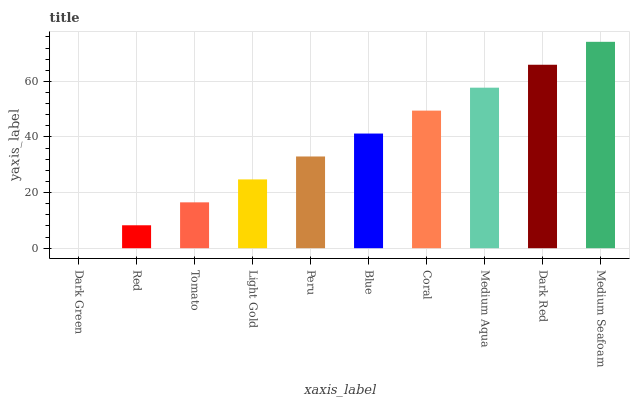Is Dark Green the minimum?
Answer yes or no. Yes. Is Medium Seafoam the maximum?
Answer yes or no. Yes. Is Red the minimum?
Answer yes or no. No. Is Red the maximum?
Answer yes or no. No. Is Red greater than Dark Green?
Answer yes or no. Yes. Is Dark Green less than Red?
Answer yes or no. Yes. Is Dark Green greater than Red?
Answer yes or no. No. Is Red less than Dark Green?
Answer yes or no. No. Is Blue the high median?
Answer yes or no. Yes. Is Peru the low median?
Answer yes or no. Yes. Is Tomato the high median?
Answer yes or no. No. Is Tomato the low median?
Answer yes or no. No. 